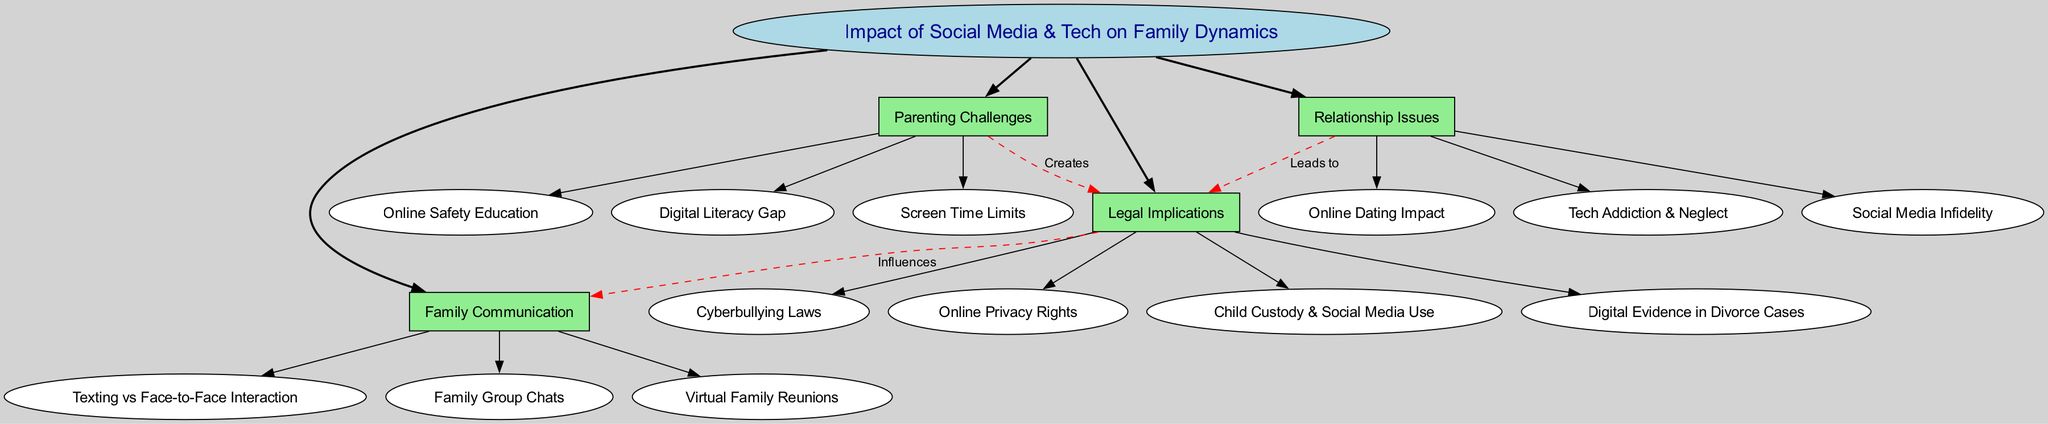What is the central concept of the diagram? The central concept is specifically labeled in the diagram and is the primary topic being addressed. It is explicitly stated as "Impact of Social Media & Tech on Family Dynamics."
Answer: Impact of Social Media & Tech on Family Dynamics How many main branches are in the diagram? The main branches are visible, and by counting them, we can determine the total. There are four main branches clearly labeled.
Answer: 4 Which sub-branch is associated with "Relationship Issues"? The sub-branches are connected to their respective main branches, and one can find that "Social Media Infidelity," being under "Relationship Issues," is an example.
Answer: Social Media Infidelity What influences family communication according to the diagram? By examining the connections indicated in the diagram, it can be seen that "Legal Implications" influences family communication.
Answer: Legal Implications What does "Parenting Challenges" create in relation to legal aspects? The connections in the diagram illustrate that "Parenting Challenges" creates "Legal Implications," highlighting an interaction between these two branches.
Answer: Legal Implications Which sub-branch discusses online safety? Looking at the sub-branches under "Parenting Challenges," we can identify that "Online Safety Education" pertains to online safety.
Answer: Online Safety Education What are the two branches connected by a dashed line? Observing the dashed lines, we can confirm that "Relationship Issues" and "Legal Implications" are connected, indicating a relationship between them.
Answer: Relationship Issues and Legal Implications Which sub-branch is related to digital evidence? By checking the sub-branches under "Legal Implications," "Digital Evidence in Divorce Cases" addresses the topic of digital evidence in legal contexts.
Answer: Digital Evidence in Divorce Cases How many sub-branches does "Family Communication" have? By counting the sub-branches listed under "Family Communication," we find there are three distinct sub-branches present.
Answer: 3 Which two branches are linked by the label "Leads to"? The diagram shows that "Relationship Issues" and "Legal Implications" are the two branches linked by the label "Leads to," illustrating a cause-effect relationship.
Answer: Relationship Issues and Legal Implications 